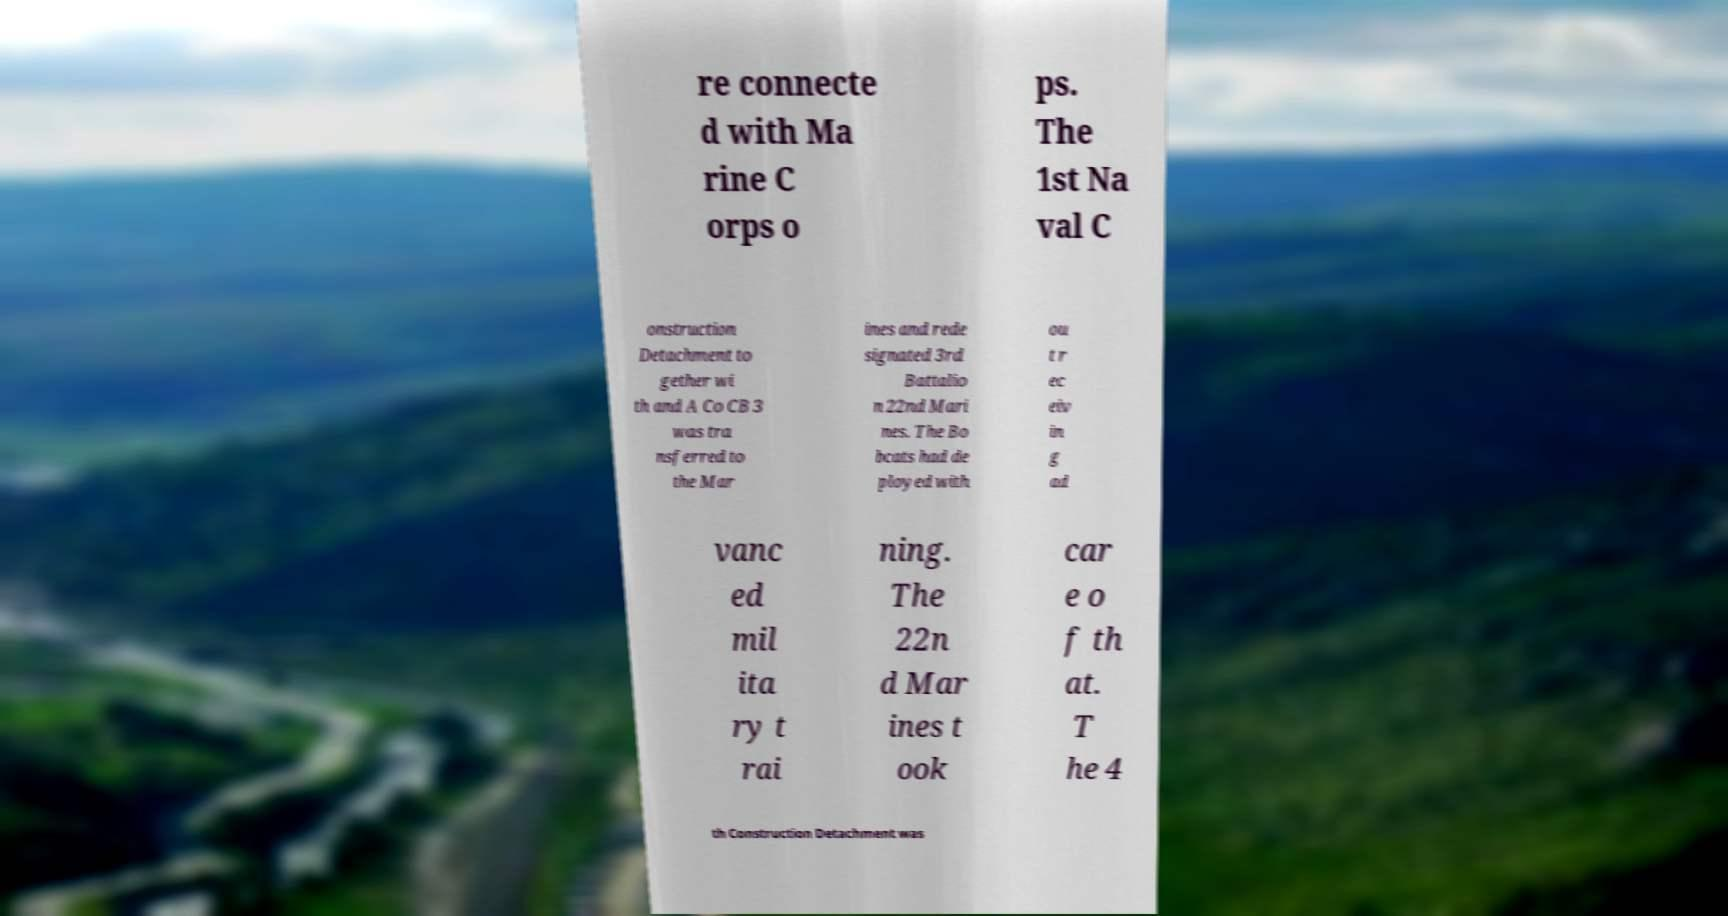Could you assist in decoding the text presented in this image and type it out clearly? re connecte d with Ma rine C orps o ps. The 1st Na val C onstruction Detachment to gether wi th and A Co CB 3 was tra nsferred to the Mar ines and rede signated 3rd Battalio n 22nd Mari nes. The Bo bcats had de ployed with ou t r ec eiv in g ad vanc ed mil ita ry t rai ning. The 22n d Mar ines t ook car e o f th at. T he 4 th Construction Detachment was 